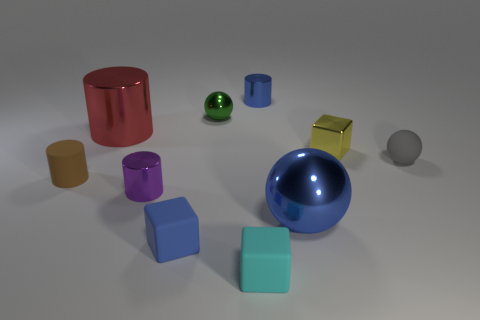Subtract all small cylinders. How many cylinders are left? 1 Subtract all blue cubes. How many cubes are left? 2 Subtract all cylinders. How many objects are left? 6 Subtract 3 cubes. How many cubes are left? 0 Subtract all yellow blocks. How many blue balls are left? 1 Subtract all cyan cylinders. Subtract all yellow balls. How many cylinders are left? 4 Subtract all small brown objects. Subtract all purple metal things. How many objects are left? 8 Add 3 gray matte things. How many gray matte things are left? 4 Add 9 cyan cubes. How many cyan cubes exist? 10 Subtract 1 gray balls. How many objects are left? 9 